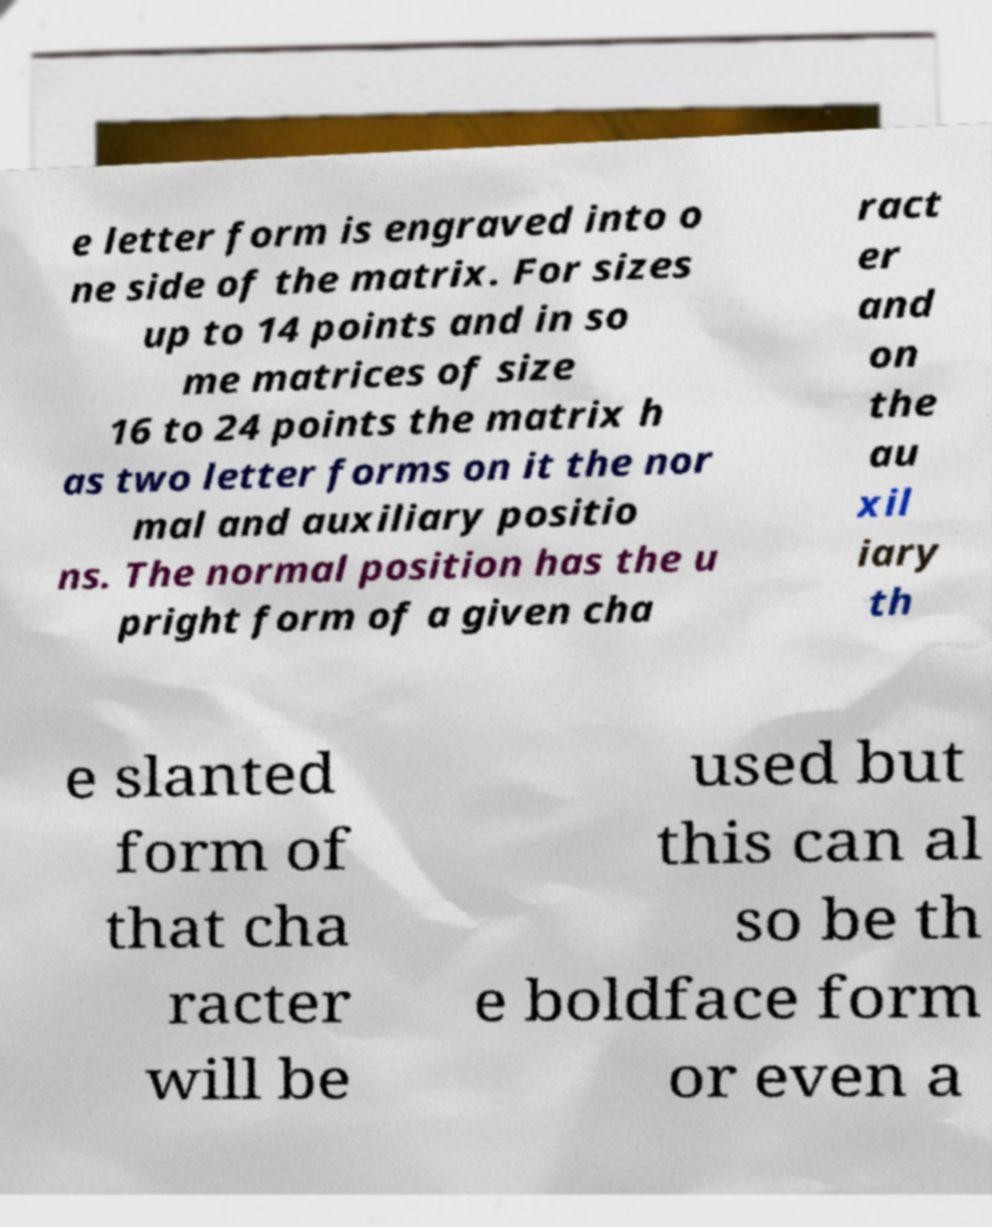Could you assist in decoding the text presented in this image and type it out clearly? e letter form is engraved into o ne side of the matrix. For sizes up to 14 points and in so me matrices of size 16 to 24 points the matrix h as two letter forms on it the nor mal and auxiliary positio ns. The normal position has the u pright form of a given cha ract er and on the au xil iary th e slanted form of that cha racter will be used but this can al so be th e boldface form or even a 